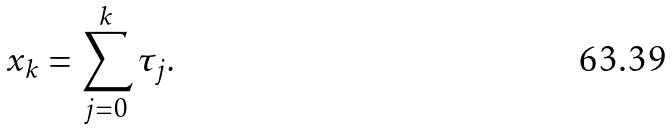Convert formula to latex. <formula><loc_0><loc_0><loc_500><loc_500>x _ { k } = \sum ^ { k } _ { j = 0 } \tau _ { j } .</formula> 